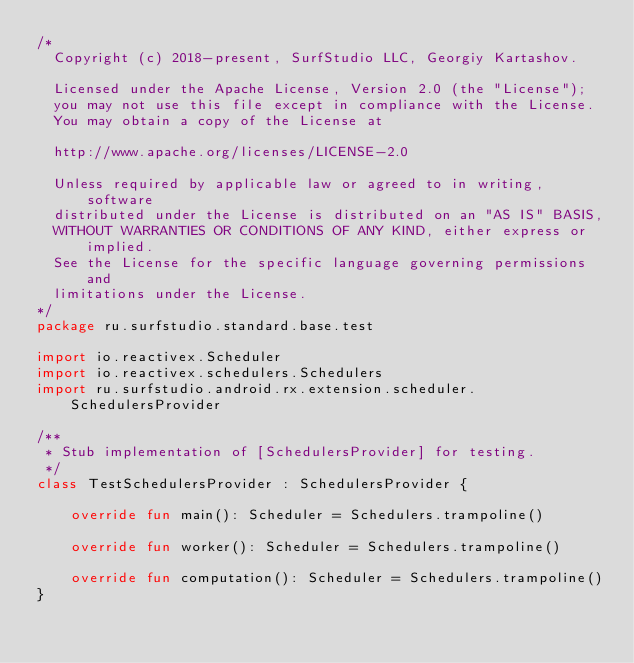Convert code to text. <code><loc_0><loc_0><loc_500><loc_500><_Kotlin_>/*
  Copyright (c) 2018-present, SurfStudio LLC, Georgiy Kartashov.

  Licensed under the Apache License, Version 2.0 (the "License");
  you may not use this file except in compliance with the License.
  You may obtain a copy of the License at

  http://www.apache.org/licenses/LICENSE-2.0

  Unless required by applicable law or agreed to in writing, software
  distributed under the License is distributed on an "AS IS" BASIS,
  WITHOUT WARRANTIES OR CONDITIONS OF ANY KIND, either express or implied.
  See the License for the specific language governing permissions and
  limitations under the License.
*/
package ru.surfstudio.standard.base.test

import io.reactivex.Scheduler
import io.reactivex.schedulers.Schedulers
import ru.surfstudio.android.rx.extension.scheduler.SchedulersProvider

/**
 * Stub implementation of [SchedulersProvider] for testing.
 */
class TestSchedulersProvider : SchedulersProvider {

    override fun main(): Scheduler = Schedulers.trampoline()

    override fun worker(): Scheduler = Schedulers.trampoline()

    override fun computation(): Scheduler = Schedulers.trampoline()
}
</code> 